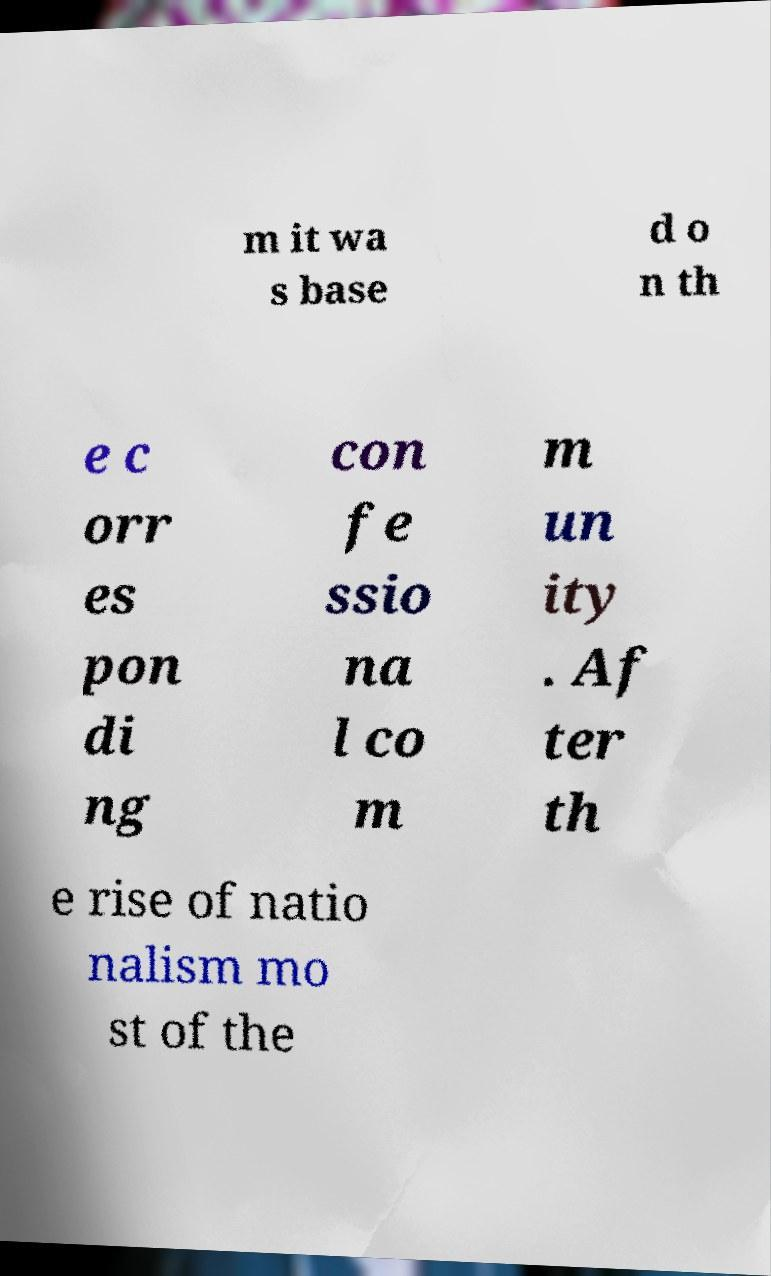Could you assist in decoding the text presented in this image and type it out clearly? m it wa s base d o n th e c orr es pon di ng con fe ssio na l co m m un ity . Af ter th e rise of natio nalism mo st of the 